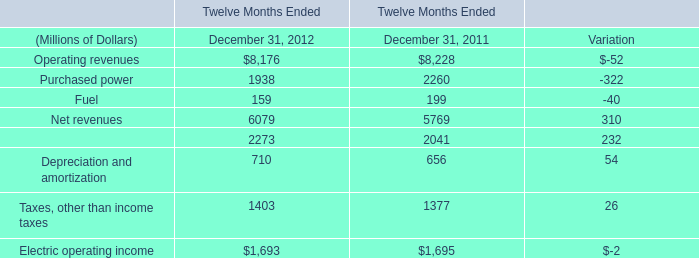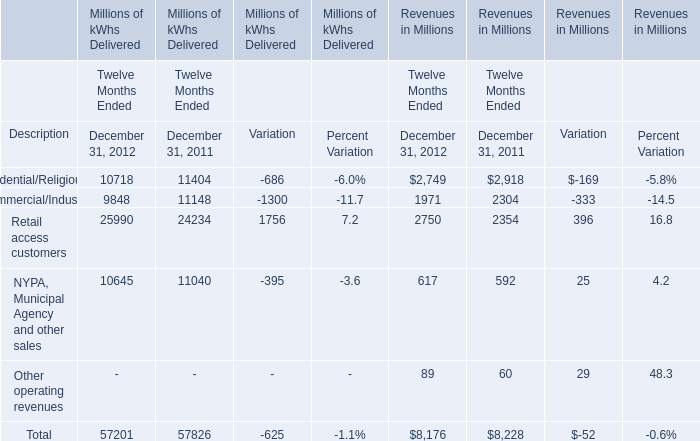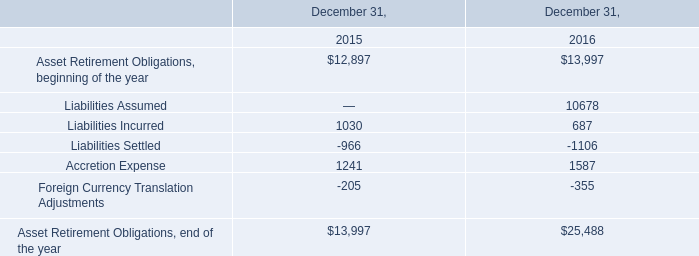What is the total amount of Accretion Expense of December 31, 2015, Commercial/Industrial of Millions of kWhs Delivered Variation, and Retail access customers of Revenues in Millions Twelve Months Ended December 31, 2012 ? 
Computations: ((1241.0 + 1300.0) + 2750.0)
Answer: 5291.0. 